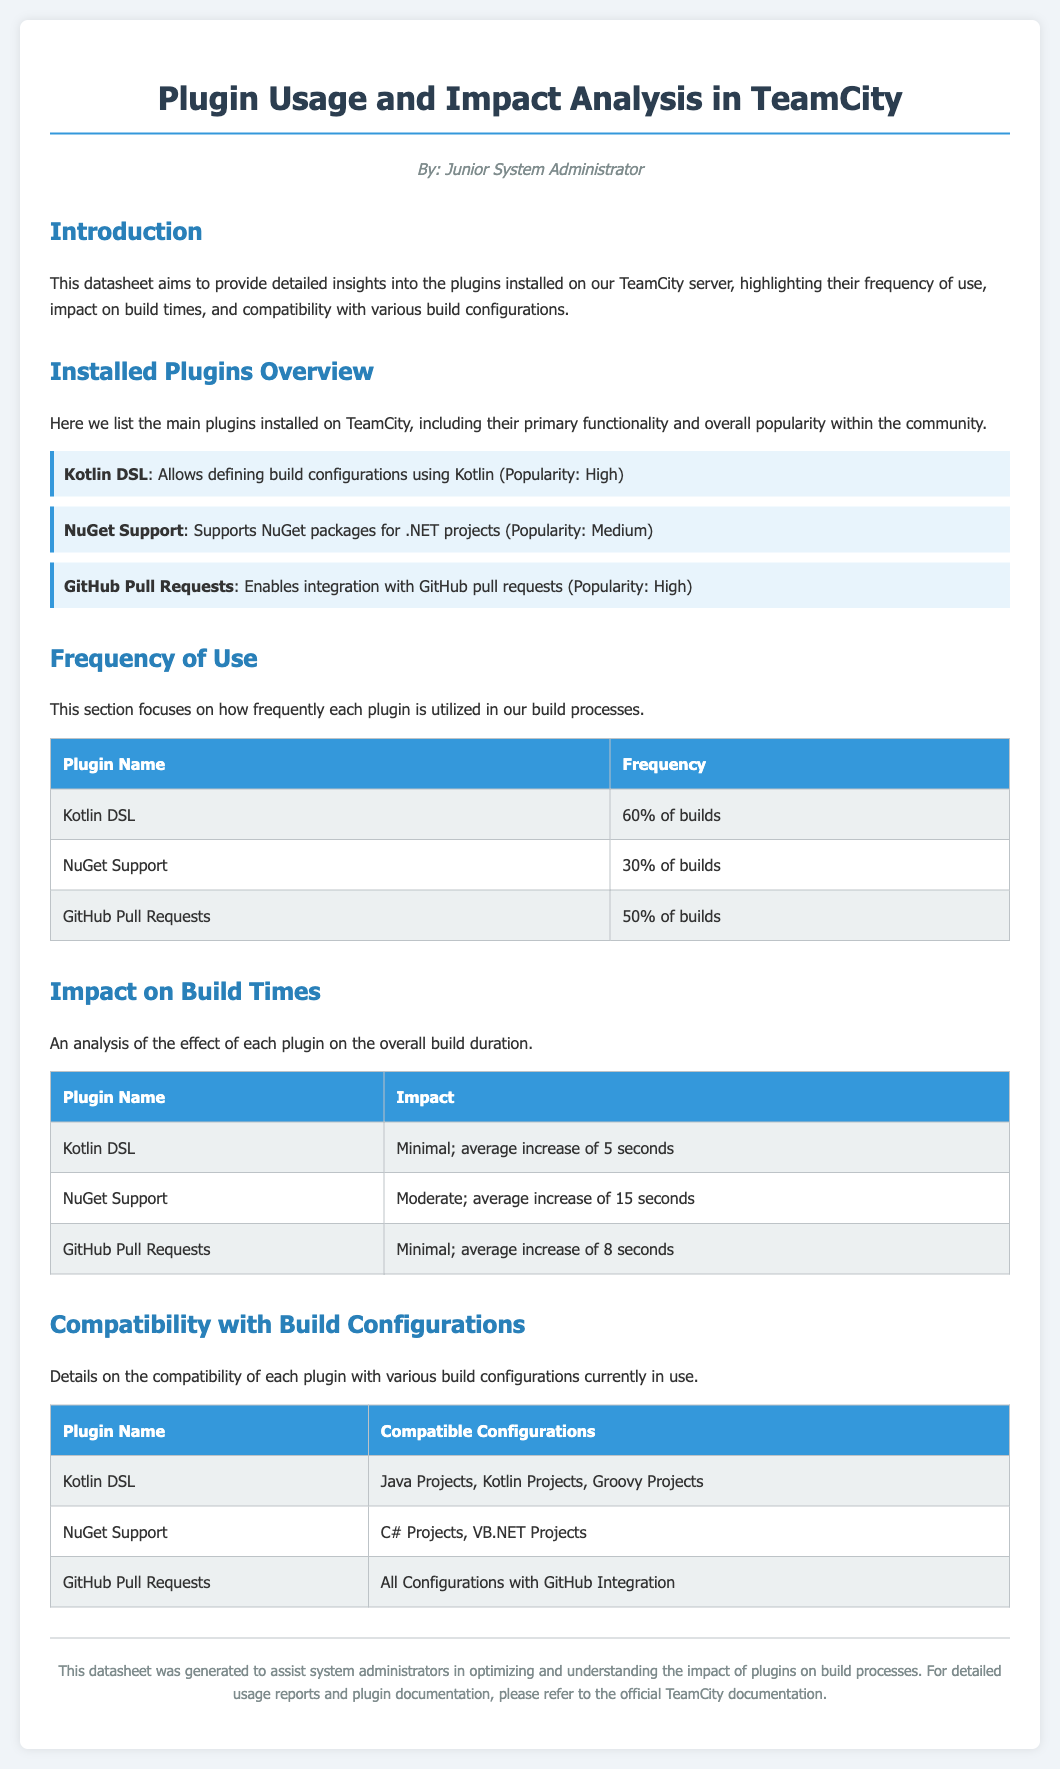What is the primary functionality of the Kotlin DSL plugin? The primary functionality of the Kotlin DSL plugin is to allow defining build configurations using Kotlin.
Answer: Allows defining build configurations using Kotlin What percentage of builds uses NuGet Support? The document states that NuGet Support is used in 30% of builds.
Answer: 30% of builds What is the average increase in build time for the NuGet Support plugin? The document indicates that the average increase in build time for the NuGet Support plugin is 15 seconds.
Answer: 15 seconds Which plugin has a compatibility with all configurations with GitHub integration? According to the document, the GitHub Pull Requests plugin is compatible with all configurations with GitHub integration.
Answer: GitHub Pull Requests Which plugin has the highest popularity? The plugins listed as high popularity in the document include Kotlin DSL and GitHub Pull Requests.
Answer: Kotlin DSL, GitHub Pull Requests What is the average increase in build time for the GitHub Pull Requests plugin? The document states that the average increase in build time for the GitHub Pull Requests plugin is 8 seconds.
Answer: 8 seconds Which build configurations are compatible with the NuGet Support plugin? The document specifies that the NuGet Support plugin is compatible with C# Projects and VB.NET Projects.
Answer: C# Projects, VB.NET Projects What is a common theme among the impact ratings for Kotlin DSL and GitHub Pull Requests? Both plugins are rated with a minimal impact on build times, with negligible increases in seconds.
Answer: Minimal How many plugins are listed in the Installed Plugins Overview section? The document lists three plugins in the Installed Plugins Overview section.
Answer: Three plugins 